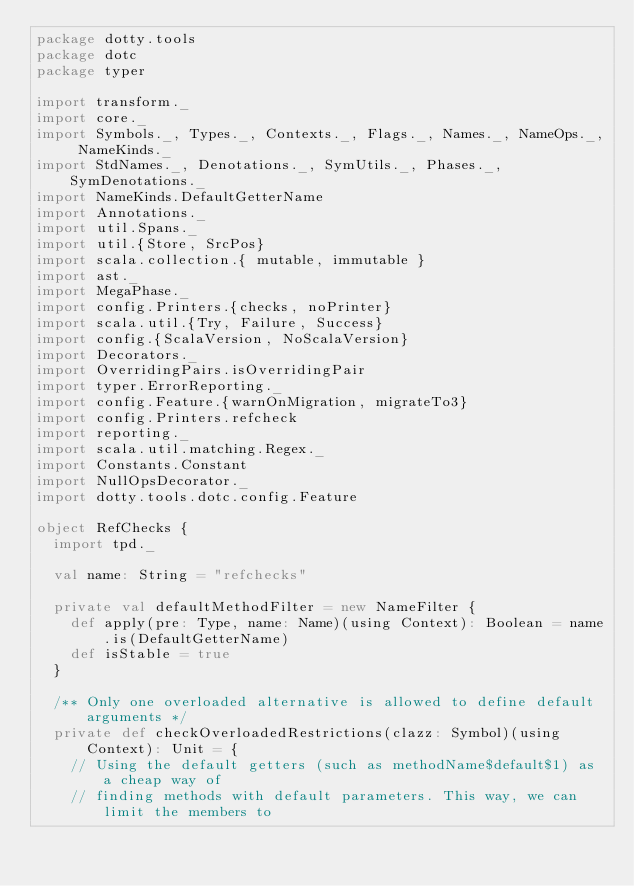Convert code to text. <code><loc_0><loc_0><loc_500><loc_500><_Scala_>package dotty.tools
package dotc
package typer

import transform._
import core._
import Symbols._, Types._, Contexts._, Flags._, Names._, NameOps._, NameKinds._
import StdNames._, Denotations._, SymUtils._, Phases._, SymDenotations._
import NameKinds.DefaultGetterName
import Annotations._
import util.Spans._
import util.{Store, SrcPos}
import scala.collection.{ mutable, immutable }
import ast._
import MegaPhase._
import config.Printers.{checks, noPrinter}
import scala.util.{Try, Failure, Success}
import config.{ScalaVersion, NoScalaVersion}
import Decorators._
import OverridingPairs.isOverridingPair
import typer.ErrorReporting._
import config.Feature.{warnOnMigration, migrateTo3}
import config.Printers.refcheck
import reporting._
import scala.util.matching.Regex._
import Constants.Constant
import NullOpsDecorator._
import dotty.tools.dotc.config.Feature

object RefChecks {
  import tpd._

  val name: String = "refchecks"

  private val defaultMethodFilter = new NameFilter {
    def apply(pre: Type, name: Name)(using Context): Boolean = name.is(DefaultGetterName)
    def isStable = true
  }

  /** Only one overloaded alternative is allowed to define default arguments */
  private def checkOverloadedRestrictions(clazz: Symbol)(using Context): Unit = {
    // Using the default getters (such as methodName$default$1) as a cheap way of
    // finding methods with default parameters. This way, we can limit the members to</code> 